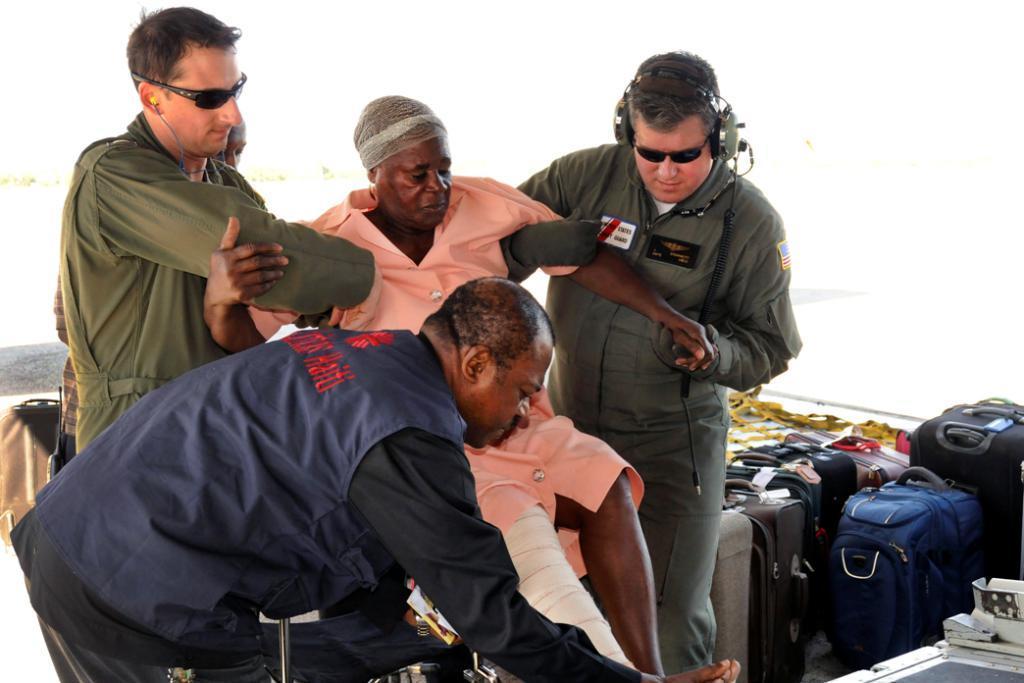Describe this image in one or two sentences. In this image we can see a persons holding a old man. On the right side of the image we can see luggage. 